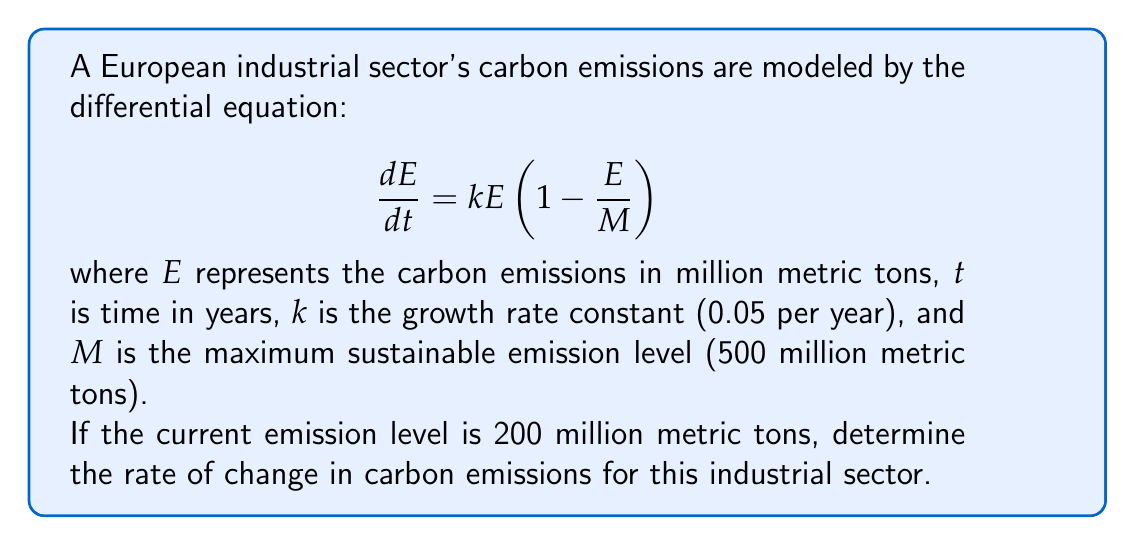Help me with this question. To solve this problem, we need to follow these steps:

1. Identify the given parameters:
   $E = 200$ million metric tons
   $k = 0.05$ per year
   $M = 500$ million metric tons

2. Substitute these values into the differential equation:

   $$ \frac{dE}{dt} = 0.05 \cdot 200 \cdot (1 - \frac{200}{500}) $$

3. Simplify the expression inside the parentheses:

   $$ \frac{dE}{dt} = 0.05 \cdot 200 \cdot (1 - 0.4) $$
   $$ \frac{dE}{dt} = 0.05 \cdot 200 \cdot 0.6 $$

4. Calculate the final result:

   $$ \frac{dE}{dt} = 0.05 \cdot 200 \cdot 0.6 = 6 $$

The rate of change in carbon emissions is 6 million metric tons per year.
Answer: The rate of change in carbon emissions for the European industrial sector is 6 million metric tons per year. 